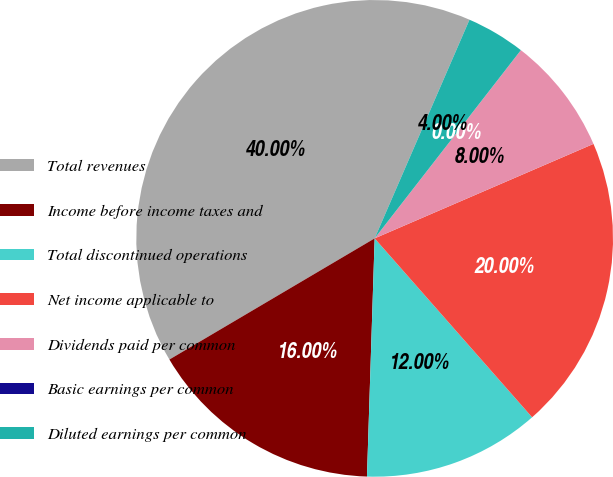Convert chart to OTSL. <chart><loc_0><loc_0><loc_500><loc_500><pie_chart><fcel>Total revenues<fcel>Income before income taxes and<fcel>Total discontinued operations<fcel>Net income applicable to<fcel>Dividends paid per common<fcel>Basic earnings per common<fcel>Diluted earnings per common<nl><fcel>40.0%<fcel>16.0%<fcel>12.0%<fcel>20.0%<fcel>8.0%<fcel>0.0%<fcel>4.0%<nl></chart> 